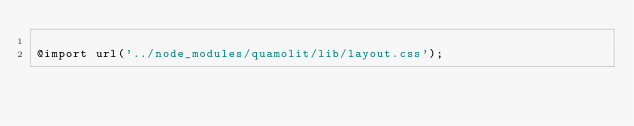<code> <loc_0><loc_0><loc_500><loc_500><_CSS_>
@import url('../node_modules/quamolit/lib/layout.css');
</code> 